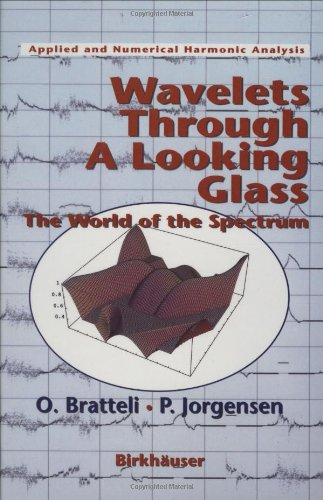Who wrote this book? The book 'Wavelets Through a Looking Glass: The World of the Spectrum' was co-written by Ola Bratteli and Palle E.T. Jorgensen. 